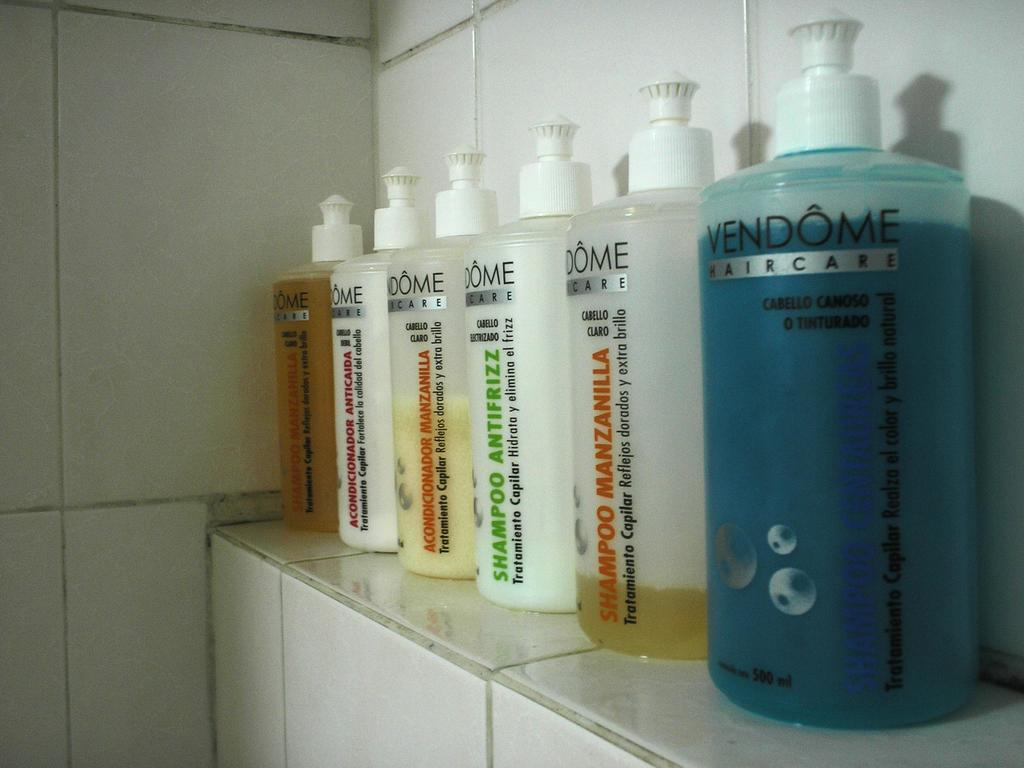<image>
Render a clear and concise summary of the photo. A row of various Vendome brand hair care products. 